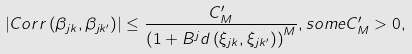Convert formula to latex. <formula><loc_0><loc_0><loc_500><loc_500>\left | C o r r \left ( \beta _ { j k } , \beta _ { j k ^ { \prime } } \right ) \right | \leq \frac { C _ { M } ^ { \prime } } { \left ( 1 + B ^ { j } d \left ( \xi _ { j k } , \xi _ { j k ^ { \prime } } \right ) \right ) ^ { M } } , s o m e C _ { M } ^ { \prime } > 0 ,</formula> 